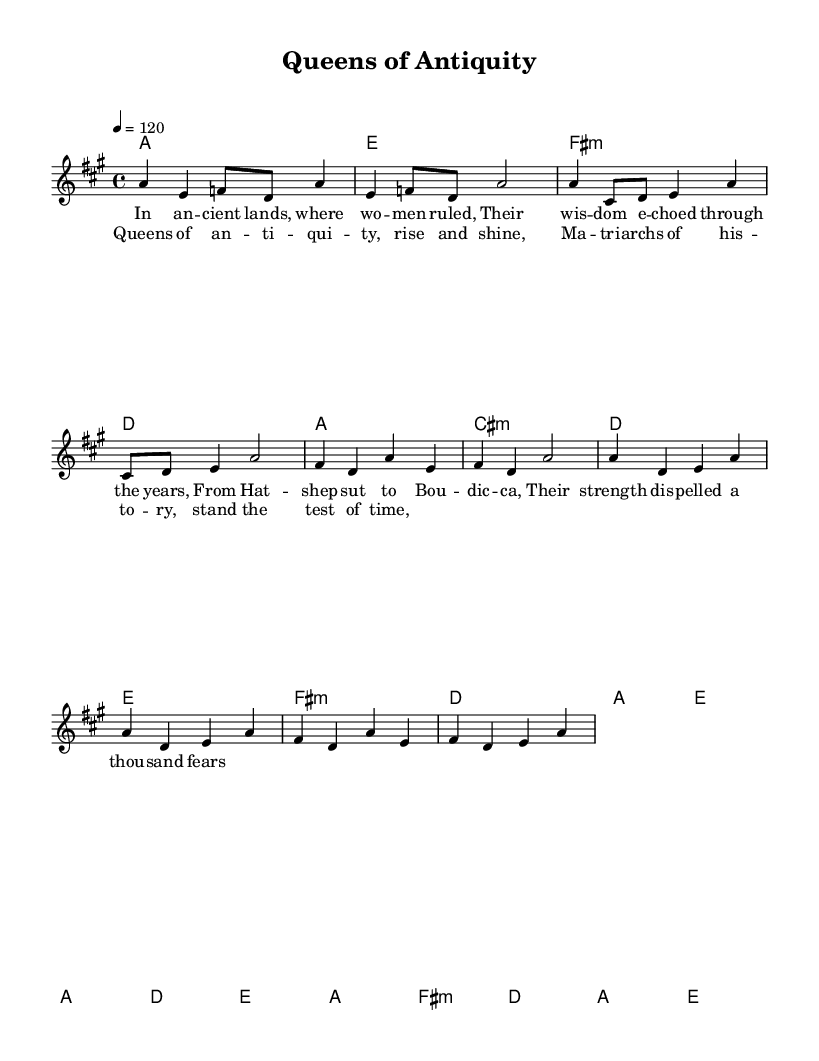What is the key signature of this music? The key signature is A major, which has three sharps (F#, C#, and G#). This is determined by looking at the global section of the LilyPond code where it specifies \key a \major.
Answer: A major What is the time signature of this music? The time signature is 4/4, as indicated in the global section of the code with \time 4/4. This means there are four beats per measure, and the quarter note gets one beat.
Answer: 4/4 What is the tempo of the piece? The tempo is 120 beats per minute, as shown by the tempo directive in the global section which states \tempo 4 = 120. This indicates how fast the music should be played.
Answer: 120 How many measures are there in the chorus? The chorus consists of four measures. This is observed in the melody section where the chorus lyrics are placed, and there are four corresponding measures of melody.
Answer: Four measures Which historical figures are referenced in the lyrics? The lyrics reference Hatshepsut and Boudicca, which are noted in the verse section of the provided sheet music. These names indicate the powerful women from ancient history.
Answer: Hatshepsut, Boudicca What genre does this music belong to? The music belongs to the disco genre, as indicated by the upbeat style and lyrical themes that celebrate matriarchal societies, typical of disco's celebratory nature.
Answer: Disco What is the emotional tone conveyed in the chorus? The emotional tone in the chorus is one of empowerment and pride, as indicated by the phrases "rise and shine" and "stand the test of time," suggesting a celebration of women's historical strength.
Answer: Empowerment 